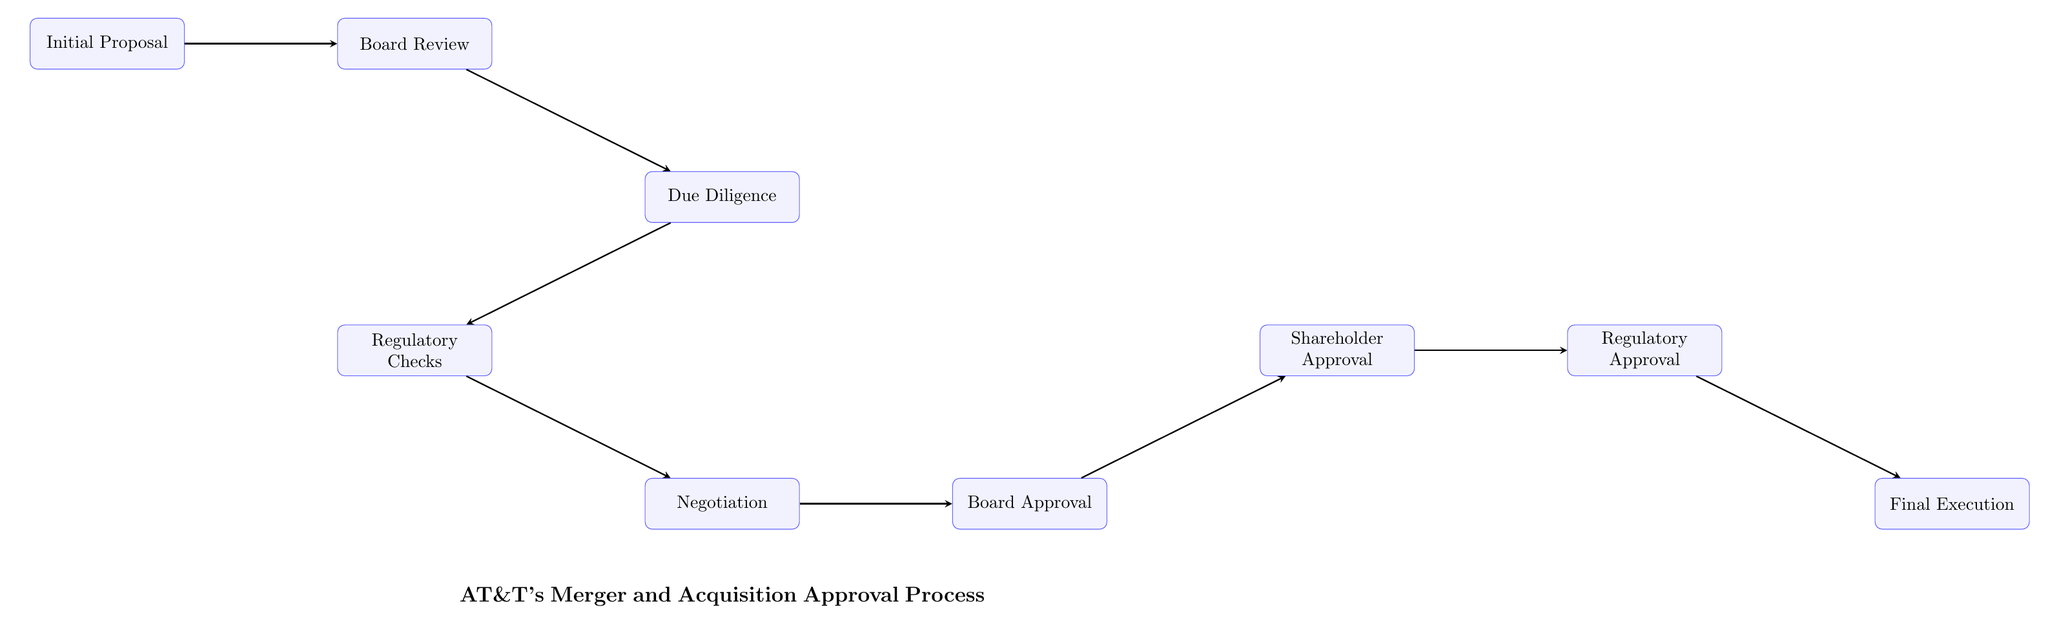What is the first step in AT&T's merger and acquisition approval process? The diagram shows that the initial step is the "Initial Proposal," where management identifies potential merger/acquisition targets.
Answer: Initial Proposal How many nodes are in the process outlined in the diagram? By counting all the distinct boxes representing various steps, there are a total of nine nodes listed in the diagram.
Answer: 9 What step follows due diligence in the approval process? Following "Due Diligence," the next step in the flow is "Regulatory Checks," as indicated by the arrow pointing downwards from due diligence to regulatory checks.
Answer: Regulatory Checks Which steps require approval from AT&T's Board of Directors? The process requires approval at two points: first during "Board Review" and secondly during "Board Approval," which is a step following negotiation.
Answer: Board Review, Board Approval What is the last step in the approval process? The final step, as indicated in the flow chart, is "Final Execution," which involves finalizing the merger/acquisition agreement.
Answer: Final Execution What nodes involve shareholder involvement in the process? Shareholders are involved in the process specifically during the "Shareholder Approval" step, which follows "Board Approval."
Answer: Shareholder Approval Which step directly precedes regulatory approval? The step that comes right before "Regulatory Approval" is "Shareholder Approval," as shown by the arrow connecting these two nodes in the diagram.
Answer: Shareholder Approval What are the two main actions taken in the negotiation process? The negotiation process primarily involves negotiating terms and conditions between AT&T and the target company, prior to seeking board approval.
Answer: Terms and conditions negotiation 